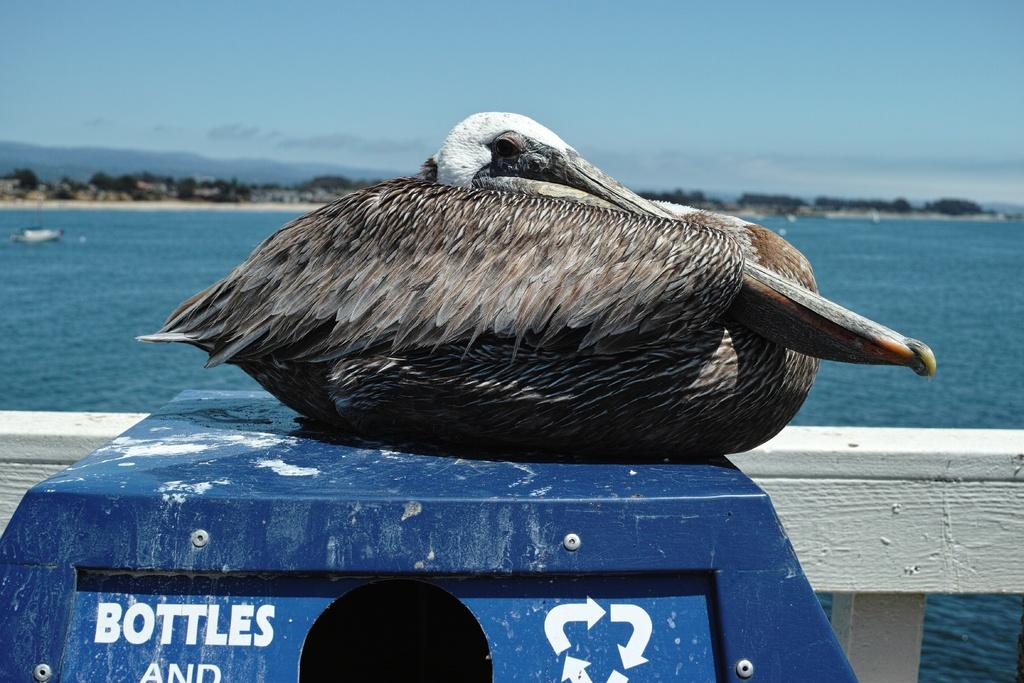What type of animal can be seen in the image? There is a bird in the image. Where is the bird located? The bird is sitting on a blue box. What else can be seen in the image besides the bird? There is water visible in the image. What type of trouble is the bird causing with the lamp in the image? There is no lamp present in the image, and therefore no trouble involving a lamp can be observed. 